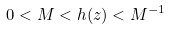Convert formula to latex. <formula><loc_0><loc_0><loc_500><loc_500>0 < M < h ( z ) < M ^ { - 1 }</formula> 